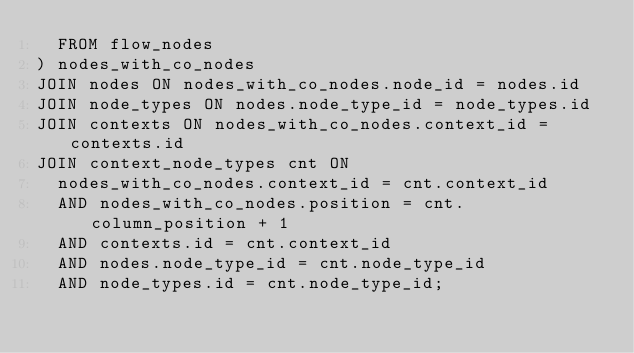<code> <loc_0><loc_0><loc_500><loc_500><_SQL_>  FROM flow_nodes
) nodes_with_co_nodes
JOIN nodes ON nodes_with_co_nodes.node_id = nodes.id
JOIN node_types ON nodes.node_type_id = node_types.id
JOIN contexts ON nodes_with_co_nodes.context_id = contexts.id
JOIN context_node_types cnt ON
  nodes_with_co_nodes.context_id = cnt.context_id
  AND nodes_with_co_nodes.position = cnt.column_position + 1
  AND contexts.id = cnt.context_id
  AND nodes.node_type_id = cnt.node_type_id
  AND node_types.id = cnt.node_type_id;
</code> 